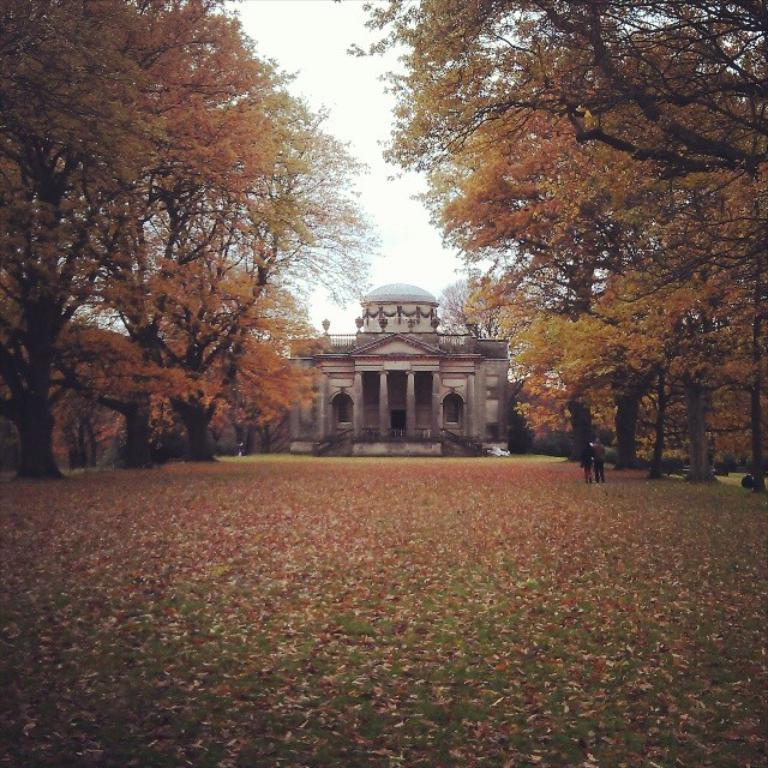What is on the ground in the image? There are leaves on the ground in the image. What can be seen in the background of the image? There are trees and at least one building in the background of the image. Are there any people visible in the image? Yes, there are people in the background of the image. What type of knee can be seen in the image? There is no knee visible in the image. Is there a river flowing through the image? There is no river present in the image. 